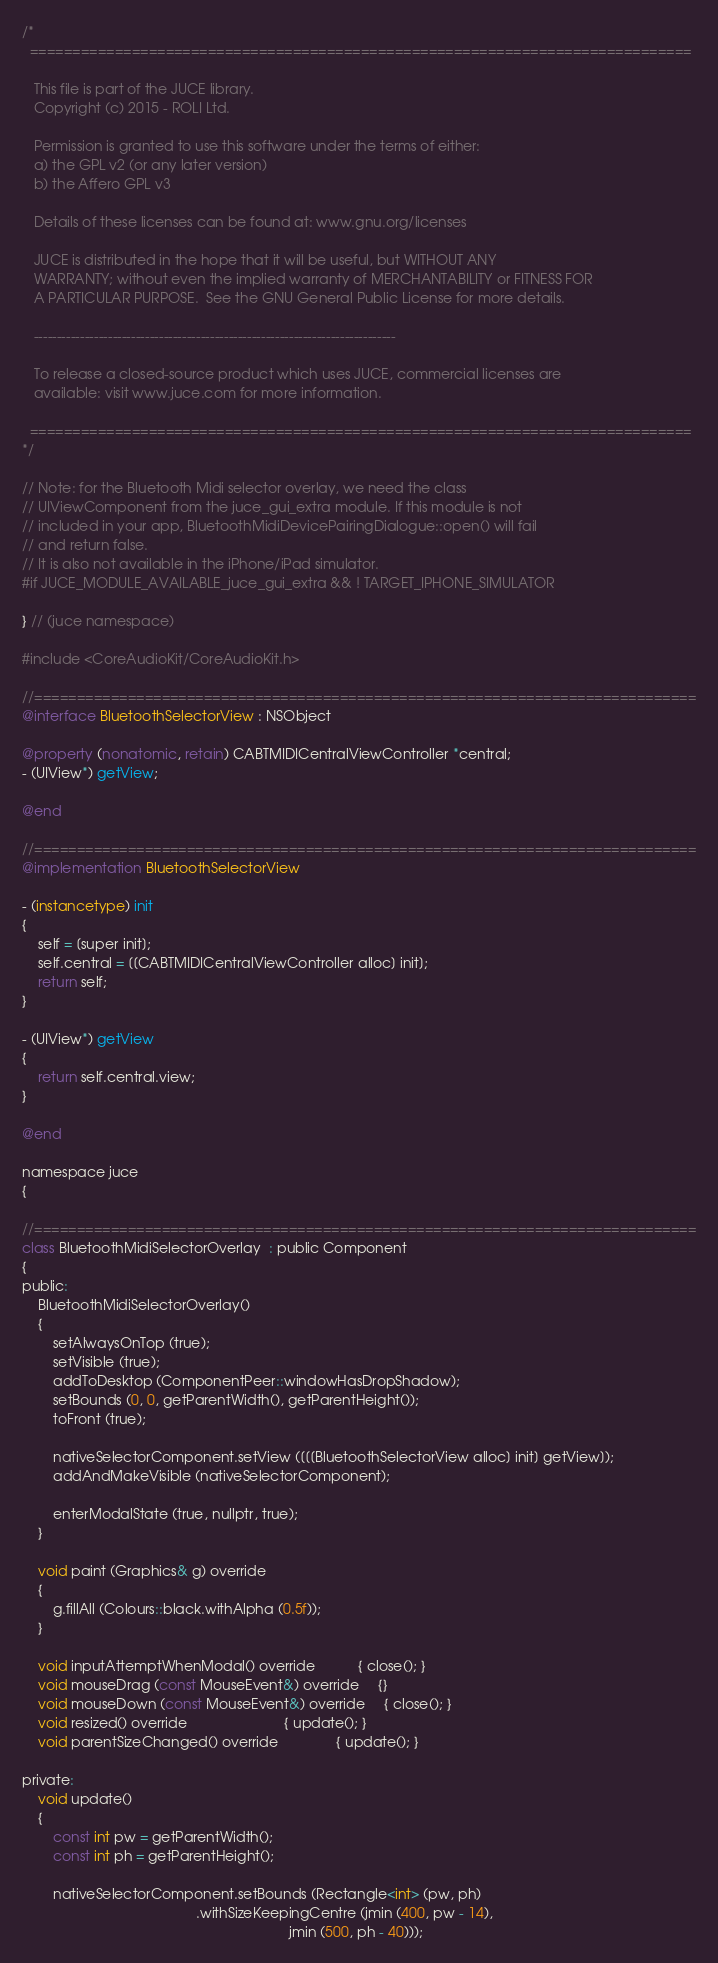<code> <loc_0><loc_0><loc_500><loc_500><_ObjectiveC_>/*
  ==============================================================================

   This file is part of the JUCE library.
   Copyright (c) 2015 - ROLI Ltd.

   Permission is granted to use this software under the terms of either:
   a) the GPL v2 (or any later version)
   b) the Affero GPL v3

   Details of these licenses can be found at: www.gnu.org/licenses

   JUCE is distributed in the hope that it will be useful, but WITHOUT ANY
   WARRANTY; without even the implied warranty of MERCHANTABILITY or FITNESS FOR
   A PARTICULAR PURPOSE.  See the GNU General Public License for more details.

   ------------------------------------------------------------------------------

   To release a closed-source product which uses JUCE, commercial licenses are
   available: visit www.juce.com for more information.

  ==============================================================================
*/

// Note: for the Bluetooth Midi selector overlay, we need the class
// UIViewComponent from the juce_gui_extra module. If this module is not
// included in your app, BluetoothMidiDevicePairingDialogue::open() will fail
// and return false.
// It is also not available in the iPhone/iPad simulator.
#if JUCE_MODULE_AVAILABLE_juce_gui_extra && ! TARGET_IPHONE_SIMULATOR

} // (juce namespace)

#include <CoreAudioKit/CoreAudioKit.h>

//==============================================================================
@interface BluetoothSelectorView : NSObject

@property (nonatomic, retain) CABTMIDICentralViewController *central;
- (UIView*) getView;

@end

//==============================================================================
@implementation BluetoothSelectorView

- (instancetype) init
{
    self = [super init];
    self.central = [[CABTMIDICentralViewController alloc] init];
    return self;
}

- (UIView*) getView
{
    return self.central.view;
}

@end

namespace juce
{

//==============================================================================
class BluetoothMidiSelectorOverlay  : public Component
{
public:
    BluetoothMidiSelectorOverlay()
    {
        setAlwaysOnTop (true);
        setVisible (true);
        addToDesktop (ComponentPeer::windowHasDropShadow);
        setBounds (0, 0, getParentWidth(), getParentHeight());
        toFront (true);

        nativeSelectorComponent.setView ([[[BluetoothSelectorView alloc] init] getView]);
        addAndMakeVisible (nativeSelectorComponent);

        enterModalState (true, nullptr, true);
    }

    void paint (Graphics& g) override
    {
        g.fillAll (Colours::black.withAlpha (0.5f));
    }

    void inputAttemptWhenModal() override           { close(); }
    void mouseDrag (const MouseEvent&) override     {}
    void mouseDown (const MouseEvent&) override     { close(); }
    void resized() override                         { update(); }
    void parentSizeChanged() override               { update(); }

private:
    void update()
    {
        const int pw = getParentWidth();
        const int ph = getParentHeight();

        nativeSelectorComponent.setBounds (Rectangle<int> (pw, ph)
                                             .withSizeKeepingCentre (jmin (400, pw - 14),
                                                                     jmin (500, ph - 40)));</code> 